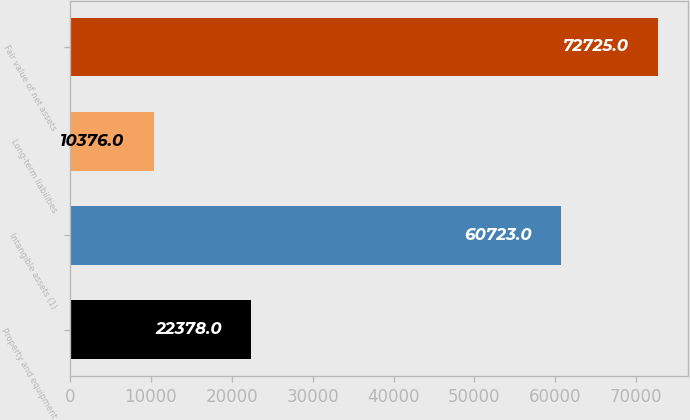<chart> <loc_0><loc_0><loc_500><loc_500><bar_chart><fcel>Property and equipment<fcel>Intangible assets (1)<fcel>Long-term liabilities<fcel>Fair value of net assets<nl><fcel>22378<fcel>60723<fcel>10376<fcel>72725<nl></chart> 